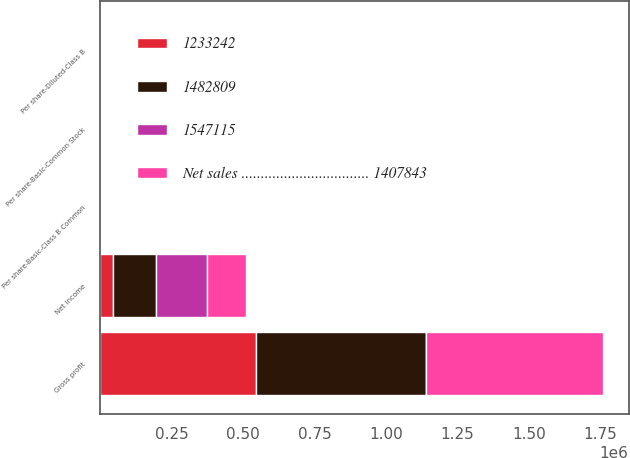Convert chart to OTSL. <chart><loc_0><loc_0><loc_500><loc_500><stacked_bar_chart><ecel><fcel>Gross profit<fcel>Net income<fcel>Per share-Basic-Class B Common<fcel>Per share-Diluted-Class B<fcel>Per share-Basic-Common Stock<nl><fcel>1482809<fcel>593980<fcel>147394<fcel>0.6<fcel>0.6<fcel>0.66<nl><fcel>1233242<fcel>546538<fcel>46723<fcel>0.19<fcel>0.19<fcel>0.21<nl><fcel>1547115<fcel>0.73<fcel>180169<fcel>0.74<fcel>0.73<fcel>0.81<nl><fcel>Net sales ................................. 1407843<fcel>619470<fcel>135513<fcel>0.55<fcel>0.55<fcel>0.61<nl></chart> 